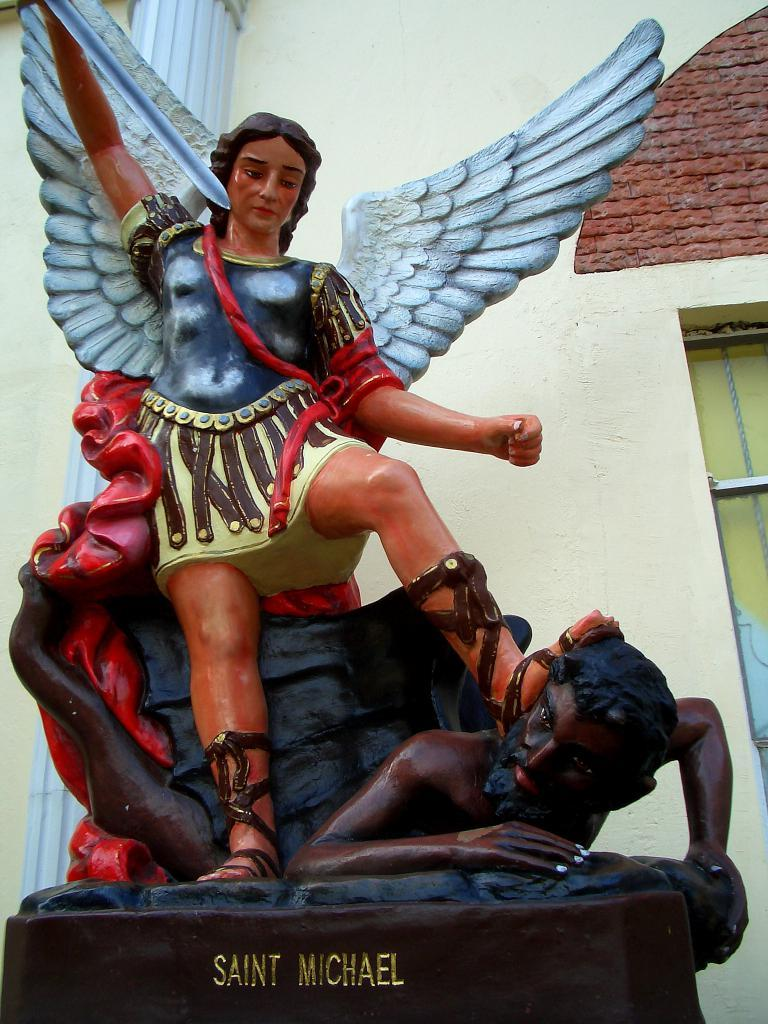What is the main subject in the image? There is a statue in the image. Can you describe the statue's surroundings? There is a wall behind the statue in the image. How many servants are attending to the statue in the image? There are no servants present in the image; it only features a statue and a wall. 